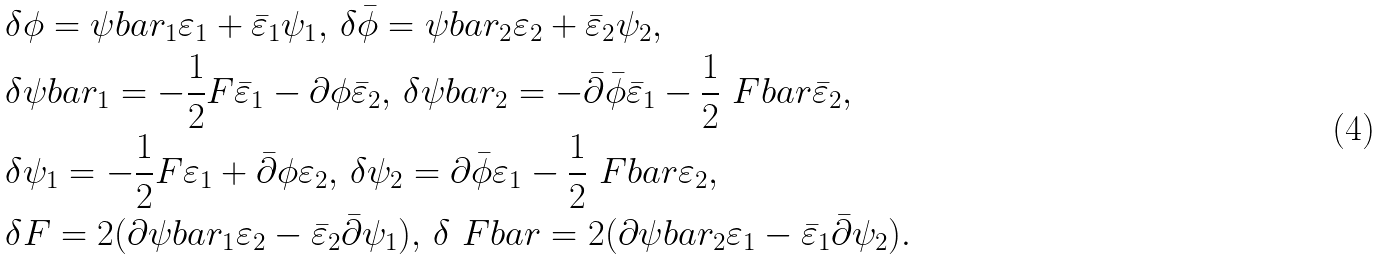Convert formula to latex. <formula><loc_0><loc_0><loc_500><loc_500>& \delta \phi = \psi b a r _ { 1 } \varepsilon _ { 1 } + \bar { \varepsilon } _ { 1 } \psi _ { 1 } , \, \delta \bar { \phi } = \psi b a r _ { 2 } \varepsilon _ { 2 } + \bar { \varepsilon } _ { 2 } \psi _ { 2 } , \\ & \delta \psi b a r _ { 1 } = - \frac { 1 } { 2 } F \bar { \varepsilon } _ { 1 } - \partial \phi \bar { \varepsilon } _ { 2 } , \, \delta \psi b a r _ { 2 } = - \bar { \partial } \bar { \phi } \bar { \varepsilon } _ { 1 } - \frac { 1 } { 2 } \ F b a r \bar { \varepsilon } _ { 2 } , \\ & \delta \psi _ { 1 } = - \frac { 1 } { 2 } F \varepsilon _ { 1 } + \bar { \partial } \phi \varepsilon _ { 2 } , \, \delta \psi _ { 2 } = \partial \bar { \phi } \varepsilon _ { 1 } - \frac { 1 } { 2 } \ F b a r \varepsilon _ { 2 } , \\ & \delta F = 2 ( \partial \psi b a r _ { 1 } \varepsilon _ { 2 } - \bar { \varepsilon } _ { 2 } \bar { \partial } \psi _ { 1 } ) , \, \delta \ F b a r = 2 ( \partial \psi b a r _ { 2 } \varepsilon _ { 1 } - \bar { \varepsilon } _ { 1 } \bar { \partial } \psi _ { 2 } ) .</formula> 